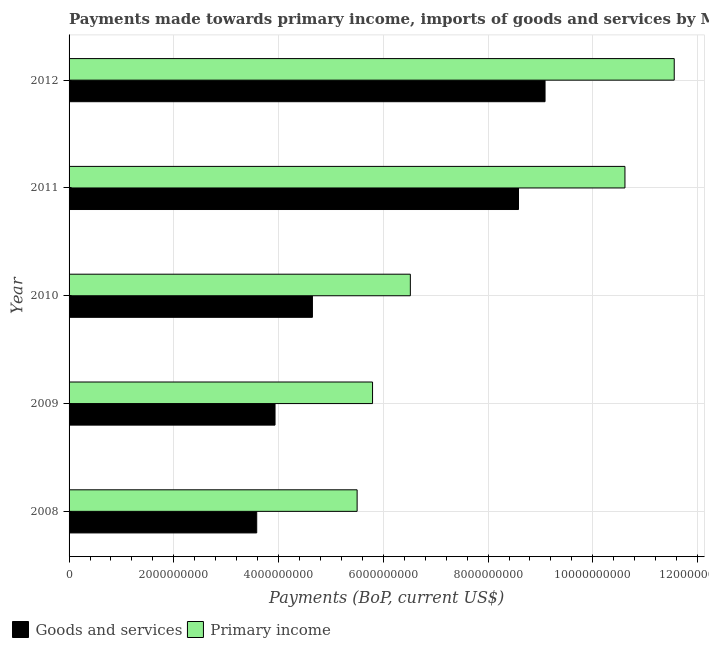How many groups of bars are there?
Give a very brief answer. 5. Are the number of bars per tick equal to the number of legend labels?
Keep it short and to the point. Yes. How many bars are there on the 3rd tick from the top?
Give a very brief answer. 2. How many bars are there on the 4th tick from the bottom?
Your answer should be very brief. 2. In how many cases, is the number of bars for a given year not equal to the number of legend labels?
Provide a succinct answer. 0. What is the payments made towards primary income in 2012?
Make the answer very short. 1.16e+1. Across all years, what is the maximum payments made towards goods and services?
Your response must be concise. 9.09e+09. Across all years, what is the minimum payments made towards primary income?
Keep it short and to the point. 5.50e+09. In which year was the payments made towards goods and services minimum?
Offer a very short reply. 2008. What is the total payments made towards primary income in the graph?
Ensure brevity in your answer.  4.00e+1. What is the difference between the payments made towards primary income in 2009 and that in 2010?
Give a very brief answer. -7.21e+08. What is the difference between the payments made towards goods and services in 2010 and the payments made towards primary income in 2011?
Your response must be concise. -5.97e+09. What is the average payments made towards goods and services per year?
Your answer should be very brief. 5.97e+09. In the year 2011, what is the difference between the payments made towards primary income and payments made towards goods and services?
Make the answer very short. 2.03e+09. What is the ratio of the payments made towards goods and services in 2010 to that in 2012?
Provide a short and direct response. 0.51. Is the difference between the payments made towards primary income in 2010 and 2011 greater than the difference between the payments made towards goods and services in 2010 and 2011?
Provide a short and direct response. No. What is the difference between the highest and the second highest payments made towards primary income?
Ensure brevity in your answer.  9.41e+08. What is the difference between the highest and the lowest payments made towards goods and services?
Your answer should be compact. 5.51e+09. In how many years, is the payments made towards goods and services greater than the average payments made towards goods and services taken over all years?
Give a very brief answer. 2. What does the 2nd bar from the top in 2010 represents?
Your answer should be compact. Goods and services. What does the 1st bar from the bottom in 2012 represents?
Provide a succinct answer. Goods and services. How many bars are there?
Your answer should be very brief. 10. How many years are there in the graph?
Your response must be concise. 5. What is the difference between two consecutive major ticks on the X-axis?
Ensure brevity in your answer.  2.00e+09. Are the values on the major ticks of X-axis written in scientific E-notation?
Your response must be concise. No. Does the graph contain any zero values?
Your answer should be very brief. No. What is the title of the graph?
Ensure brevity in your answer.  Payments made towards primary income, imports of goods and services by Myanmar. Does "current US$" appear as one of the legend labels in the graph?
Make the answer very short. No. What is the label or title of the X-axis?
Ensure brevity in your answer.  Payments (BoP, current US$). What is the label or title of the Y-axis?
Give a very brief answer. Year. What is the Payments (BoP, current US$) in Goods and services in 2008?
Offer a terse response. 3.58e+09. What is the Payments (BoP, current US$) of Primary income in 2008?
Give a very brief answer. 5.50e+09. What is the Payments (BoP, current US$) in Goods and services in 2009?
Make the answer very short. 3.93e+09. What is the Payments (BoP, current US$) of Primary income in 2009?
Provide a short and direct response. 5.79e+09. What is the Payments (BoP, current US$) in Goods and services in 2010?
Make the answer very short. 4.65e+09. What is the Payments (BoP, current US$) in Primary income in 2010?
Keep it short and to the point. 6.52e+09. What is the Payments (BoP, current US$) of Goods and services in 2011?
Offer a terse response. 8.58e+09. What is the Payments (BoP, current US$) in Primary income in 2011?
Offer a very short reply. 1.06e+1. What is the Payments (BoP, current US$) of Goods and services in 2012?
Keep it short and to the point. 9.09e+09. What is the Payments (BoP, current US$) in Primary income in 2012?
Make the answer very short. 1.16e+1. Across all years, what is the maximum Payments (BoP, current US$) in Goods and services?
Make the answer very short. 9.09e+09. Across all years, what is the maximum Payments (BoP, current US$) of Primary income?
Ensure brevity in your answer.  1.16e+1. Across all years, what is the minimum Payments (BoP, current US$) of Goods and services?
Offer a very short reply. 3.58e+09. Across all years, what is the minimum Payments (BoP, current US$) of Primary income?
Make the answer very short. 5.50e+09. What is the total Payments (BoP, current US$) in Goods and services in the graph?
Ensure brevity in your answer.  2.98e+1. What is the total Payments (BoP, current US$) of Primary income in the graph?
Offer a very short reply. 4.00e+1. What is the difference between the Payments (BoP, current US$) of Goods and services in 2008 and that in 2009?
Your response must be concise. -3.50e+08. What is the difference between the Payments (BoP, current US$) of Primary income in 2008 and that in 2009?
Ensure brevity in your answer.  -2.95e+08. What is the difference between the Payments (BoP, current US$) of Goods and services in 2008 and that in 2010?
Offer a terse response. -1.06e+09. What is the difference between the Payments (BoP, current US$) of Primary income in 2008 and that in 2010?
Make the answer very short. -1.02e+09. What is the difference between the Payments (BoP, current US$) of Goods and services in 2008 and that in 2011?
Your answer should be very brief. -5.00e+09. What is the difference between the Payments (BoP, current US$) in Primary income in 2008 and that in 2011?
Give a very brief answer. -5.11e+09. What is the difference between the Payments (BoP, current US$) of Goods and services in 2008 and that in 2012?
Make the answer very short. -5.51e+09. What is the difference between the Payments (BoP, current US$) of Primary income in 2008 and that in 2012?
Give a very brief answer. -6.05e+09. What is the difference between the Payments (BoP, current US$) in Goods and services in 2009 and that in 2010?
Your answer should be very brief. -7.14e+08. What is the difference between the Payments (BoP, current US$) in Primary income in 2009 and that in 2010?
Offer a very short reply. -7.21e+08. What is the difference between the Payments (BoP, current US$) in Goods and services in 2009 and that in 2011?
Make the answer very short. -4.65e+09. What is the difference between the Payments (BoP, current US$) of Primary income in 2009 and that in 2011?
Your answer should be compact. -4.82e+09. What is the difference between the Payments (BoP, current US$) of Goods and services in 2009 and that in 2012?
Provide a short and direct response. -5.16e+09. What is the difference between the Payments (BoP, current US$) in Primary income in 2009 and that in 2012?
Your answer should be compact. -5.76e+09. What is the difference between the Payments (BoP, current US$) of Goods and services in 2010 and that in 2011?
Your answer should be very brief. -3.93e+09. What is the difference between the Payments (BoP, current US$) in Primary income in 2010 and that in 2011?
Ensure brevity in your answer.  -4.10e+09. What is the difference between the Payments (BoP, current US$) of Goods and services in 2010 and that in 2012?
Ensure brevity in your answer.  -4.44e+09. What is the difference between the Payments (BoP, current US$) of Primary income in 2010 and that in 2012?
Your response must be concise. -5.04e+09. What is the difference between the Payments (BoP, current US$) in Goods and services in 2011 and that in 2012?
Offer a very short reply. -5.07e+08. What is the difference between the Payments (BoP, current US$) in Primary income in 2011 and that in 2012?
Provide a succinct answer. -9.41e+08. What is the difference between the Payments (BoP, current US$) of Goods and services in 2008 and the Payments (BoP, current US$) of Primary income in 2009?
Keep it short and to the point. -2.21e+09. What is the difference between the Payments (BoP, current US$) in Goods and services in 2008 and the Payments (BoP, current US$) in Primary income in 2010?
Give a very brief answer. -2.93e+09. What is the difference between the Payments (BoP, current US$) of Goods and services in 2008 and the Payments (BoP, current US$) of Primary income in 2011?
Give a very brief answer. -7.03e+09. What is the difference between the Payments (BoP, current US$) in Goods and services in 2008 and the Payments (BoP, current US$) in Primary income in 2012?
Your response must be concise. -7.97e+09. What is the difference between the Payments (BoP, current US$) of Goods and services in 2009 and the Payments (BoP, current US$) of Primary income in 2010?
Your answer should be compact. -2.58e+09. What is the difference between the Payments (BoP, current US$) in Goods and services in 2009 and the Payments (BoP, current US$) in Primary income in 2011?
Keep it short and to the point. -6.68e+09. What is the difference between the Payments (BoP, current US$) in Goods and services in 2009 and the Payments (BoP, current US$) in Primary income in 2012?
Make the answer very short. -7.62e+09. What is the difference between the Payments (BoP, current US$) in Goods and services in 2010 and the Payments (BoP, current US$) in Primary income in 2011?
Ensure brevity in your answer.  -5.97e+09. What is the difference between the Payments (BoP, current US$) in Goods and services in 2010 and the Payments (BoP, current US$) in Primary income in 2012?
Provide a succinct answer. -6.91e+09. What is the difference between the Payments (BoP, current US$) in Goods and services in 2011 and the Payments (BoP, current US$) in Primary income in 2012?
Keep it short and to the point. -2.97e+09. What is the average Payments (BoP, current US$) of Goods and services per year?
Provide a short and direct response. 5.97e+09. What is the average Payments (BoP, current US$) of Primary income per year?
Your answer should be compact. 8.00e+09. In the year 2008, what is the difference between the Payments (BoP, current US$) of Goods and services and Payments (BoP, current US$) of Primary income?
Keep it short and to the point. -1.92e+09. In the year 2009, what is the difference between the Payments (BoP, current US$) in Goods and services and Payments (BoP, current US$) in Primary income?
Your answer should be very brief. -1.86e+09. In the year 2010, what is the difference between the Payments (BoP, current US$) of Goods and services and Payments (BoP, current US$) of Primary income?
Give a very brief answer. -1.87e+09. In the year 2011, what is the difference between the Payments (BoP, current US$) in Goods and services and Payments (BoP, current US$) in Primary income?
Give a very brief answer. -2.03e+09. In the year 2012, what is the difference between the Payments (BoP, current US$) of Goods and services and Payments (BoP, current US$) of Primary income?
Your response must be concise. -2.47e+09. What is the ratio of the Payments (BoP, current US$) of Goods and services in 2008 to that in 2009?
Give a very brief answer. 0.91. What is the ratio of the Payments (BoP, current US$) of Primary income in 2008 to that in 2009?
Keep it short and to the point. 0.95. What is the ratio of the Payments (BoP, current US$) in Goods and services in 2008 to that in 2010?
Keep it short and to the point. 0.77. What is the ratio of the Payments (BoP, current US$) of Primary income in 2008 to that in 2010?
Your response must be concise. 0.84. What is the ratio of the Payments (BoP, current US$) in Goods and services in 2008 to that in 2011?
Offer a very short reply. 0.42. What is the ratio of the Payments (BoP, current US$) of Primary income in 2008 to that in 2011?
Your response must be concise. 0.52. What is the ratio of the Payments (BoP, current US$) in Goods and services in 2008 to that in 2012?
Ensure brevity in your answer.  0.39. What is the ratio of the Payments (BoP, current US$) of Primary income in 2008 to that in 2012?
Provide a succinct answer. 0.48. What is the ratio of the Payments (BoP, current US$) in Goods and services in 2009 to that in 2010?
Your response must be concise. 0.85. What is the ratio of the Payments (BoP, current US$) of Primary income in 2009 to that in 2010?
Your response must be concise. 0.89. What is the ratio of the Payments (BoP, current US$) of Goods and services in 2009 to that in 2011?
Your response must be concise. 0.46. What is the ratio of the Payments (BoP, current US$) in Primary income in 2009 to that in 2011?
Your answer should be very brief. 0.55. What is the ratio of the Payments (BoP, current US$) in Goods and services in 2009 to that in 2012?
Ensure brevity in your answer.  0.43. What is the ratio of the Payments (BoP, current US$) in Primary income in 2009 to that in 2012?
Provide a succinct answer. 0.5. What is the ratio of the Payments (BoP, current US$) of Goods and services in 2010 to that in 2011?
Your response must be concise. 0.54. What is the ratio of the Payments (BoP, current US$) of Primary income in 2010 to that in 2011?
Your response must be concise. 0.61. What is the ratio of the Payments (BoP, current US$) in Goods and services in 2010 to that in 2012?
Offer a terse response. 0.51. What is the ratio of the Payments (BoP, current US$) of Primary income in 2010 to that in 2012?
Your answer should be very brief. 0.56. What is the ratio of the Payments (BoP, current US$) of Goods and services in 2011 to that in 2012?
Make the answer very short. 0.94. What is the ratio of the Payments (BoP, current US$) of Primary income in 2011 to that in 2012?
Make the answer very short. 0.92. What is the difference between the highest and the second highest Payments (BoP, current US$) in Goods and services?
Make the answer very short. 5.07e+08. What is the difference between the highest and the second highest Payments (BoP, current US$) in Primary income?
Offer a very short reply. 9.41e+08. What is the difference between the highest and the lowest Payments (BoP, current US$) in Goods and services?
Ensure brevity in your answer.  5.51e+09. What is the difference between the highest and the lowest Payments (BoP, current US$) in Primary income?
Ensure brevity in your answer.  6.05e+09. 